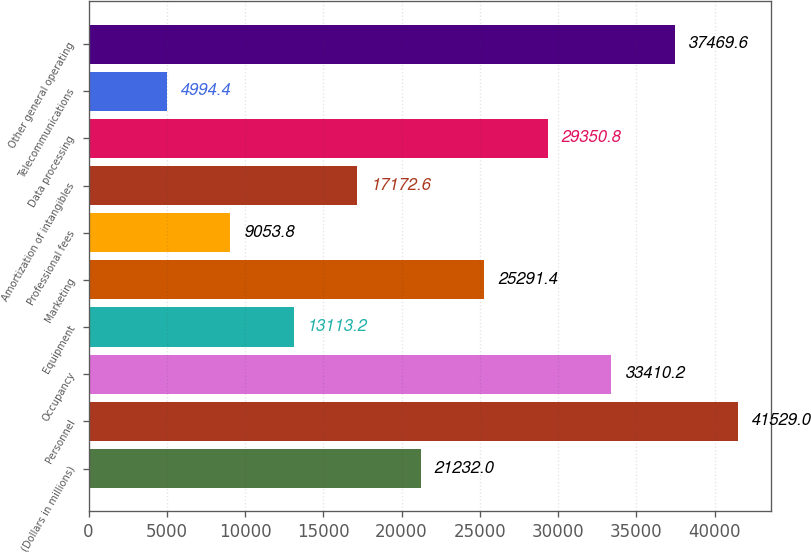<chart> <loc_0><loc_0><loc_500><loc_500><bar_chart><fcel>(Dollars in millions)<fcel>Personnel<fcel>Occupancy<fcel>Equipment<fcel>Marketing<fcel>Professional fees<fcel>Amortization of intangibles<fcel>Data processing<fcel>Telecommunications<fcel>Other general operating<nl><fcel>21232<fcel>41529<fcel>33410.2<fcel>13113.2<fcel>25291.4<fcel>9053.8<fcel>17172.6<fcel>29350.8<fcel>4994.4<fcel>37469.6<nl></chart> 